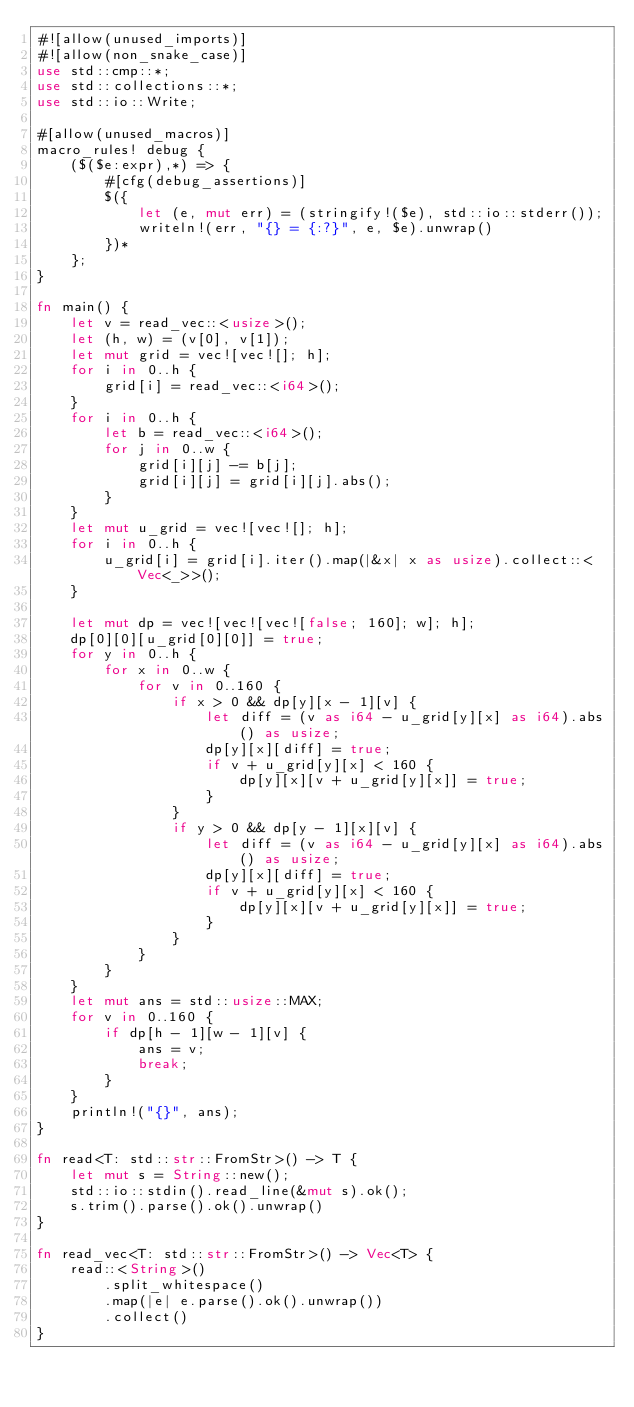Convert code to text. <code><loc_0><loc_0><loc_500><loc_500><_Rust_>#![allow(unused_imports)]
#![allow(non_snake_case)]
use std::cmp::*;
use std::collections::*;
use std::io::Write;

#[allow(unused_macros)]
macro_rules! debug {
    ($($e:expr),*) => {
        #[cfg(debug_assertions)]
        $({
            let (e, mut err) = (stringify!($e), std::io::stderr());
            writeln!(err, "{} = {:?}", e, $e).unwrap()
        })*
    };
}

fn main() {
    let v = read_vec::<usize>();
    let (h, w) = (v[0], v[1]);
    let mut grid = vec![vec![]; h];
    for i in 0..h {
        grid[i] = read_vec::<i64>();
    }
    for i in 0..h {
        let b = read_vec::<i64>();
        for j in 0..w {
            grid[i][j] -= b[j];
            grid[i][j] = grid[i][j].abs();
        }
    }
    let mut u_grid = vec![vec![]; h];
    for i in 0..h {
        u_grid[i] = grid[i].iter().map(|&x| x as usize).collect::<Vec<_>>();
    }

    let mut dp = vec![vec![vec![false; 160]; w]; h];
    dp[0][0][u_grid[0][0]] = true;
    for y in 0..h {
        for x in 0..w {
            for v in 0..160 {
                if x > 0 && dp[y][x - 1][v] {
                    let diff = (v as i64 - u_grid[y][x] as i64).abs() as usize;
                    dp[y][x][diff] = true;
                    if v + u_grid[y][x] < 160 {
                        dp[y][x][v + u_grid[y][x]] = true;
                    }
                }
                if y > 0 && dp[y - 1][x][v] {
                    let diff = (v as i64 - u_grid[y][x] as i64).abs() as usize;
                    dp[y][x][diff] = true;
                    if v + u_grid[y][x] < 160 {
                        dp[y][x][v + u_grid[y][x]] = true;
                    }
                }
            }
        }
    }
    let mut ans = std::usize::MAX;
    for v in 0..160 {
        if dp[h - 1][w - 1][v] {
            ans = v;
            break;
        }
    }
    println!("{}", ans);
}

fn read<T: std::str::FromStr>() -> T {
    let mut s = String::new();
    std::io::stdin().read_line(&mut s).ok();
    s.trim().parse().ok().unwrap()
}

fn read_vec<T: std::str::FromStr>() -> Vec<T> {
    read::<String>()
        .split_whitespace()
        .map(|e| e.parse().ok().unwrap())
        .collect()
}
</code> 